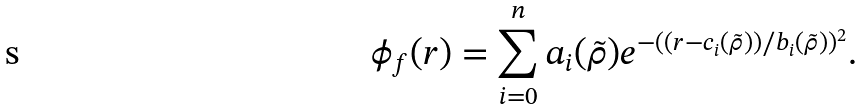Convert formula to latex. <formula><loc_0><loc_0><loc_500><loc_500>\phi _ { f } ( r ) = \sum _ { i = 0 } ^ { n } a _ { i } ( \tilde { \rho } ) e ^ { - ( ( r - c _ { i } ( \tilde { \rho } ) ) / b _ { i } ( \tilde { \rho } ) ) ^ { 2 } } .</formula> 